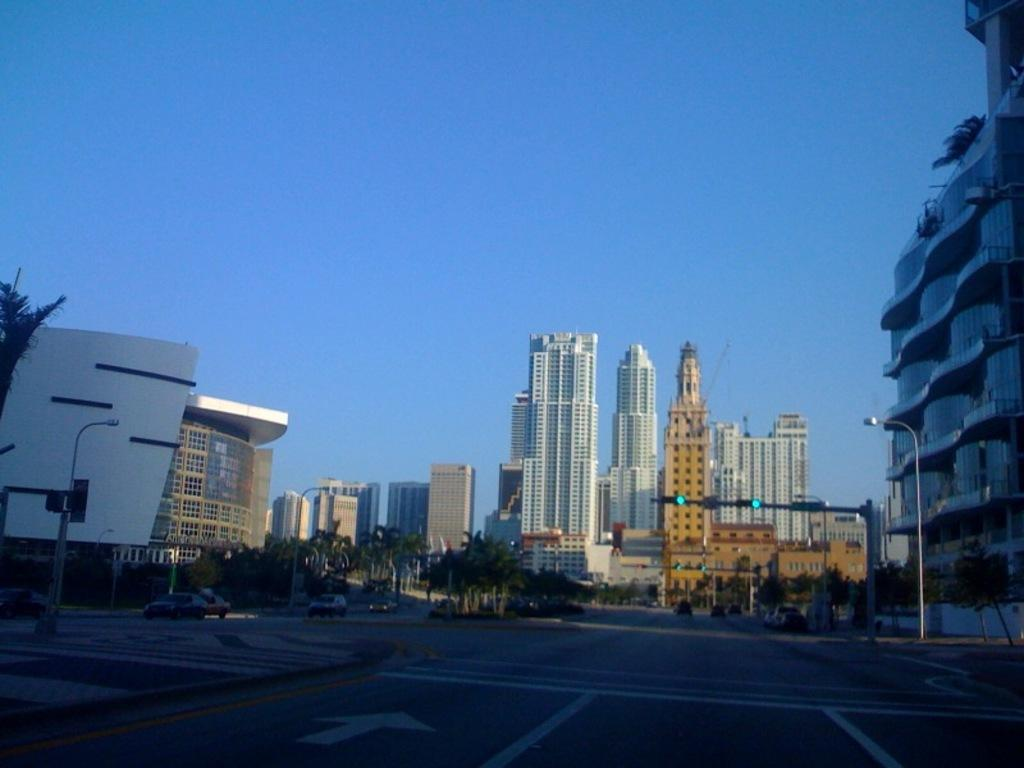What type of structures can be seen in the image? There are buildings in the image. What else can be seen in the image besides buildings? There are poles, lights, trees, vehicles on the road, and the sky visible in the background of the image. What might be used for illumination in the image? The lights in the image might be used for illumination. What type of vegetation is present in the image? There are trees in the image. Can you tell me how many times the moon is visible in the image? The moon is not visible in the image; only the sky is visible in the background. What type of seat is present in the image? There is no seat present in the image. 